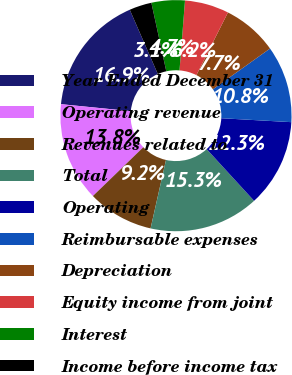<chart> <loc_0><loc_0><loc_500><loc_500><pie_chart><fcel>Year Ended December 31<fcel>Operating revenue<fcel>Revenues related to<fcel>Total<fcel>Operating<fcel>Reimbursable expenses<fcel>Depreciation<fcel>Equity income from joint<fcel>Interest<fcel>Income before income tax<nl><fcel>16.87%<fcel>13.82%<fcel>9.24%<fcel>15.34%<fcel>12.29%<fcel>10.76%<fcel>7.71%<fcel>6.18%<fcel>4.66%<fcel>3.13%<nl></chart> 